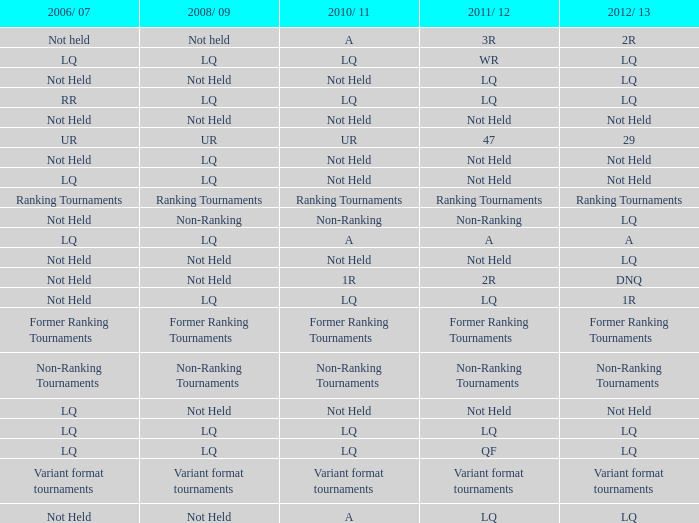What is 2006/07, when 2008/09 is LQ, and when 2010/11 is Not Held? LQ, Not Held. 